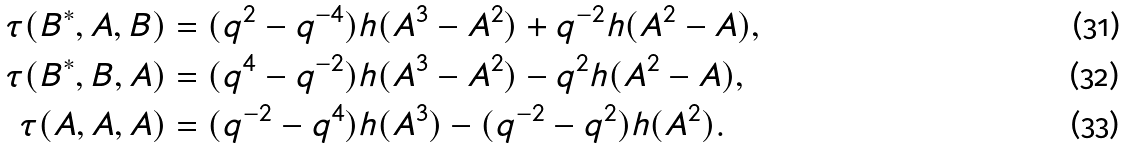Convert formula to latex. <formula><loc_0><loc_0><loc_500><loc_500>\tau ( B ^ { \ast } , A , B ) & = ( q ^ { 2 } - q ^ { - 4 } ) h ( A ^ { 3 } - A ^ { 2 } ) + q ^ { - 2 } h ( A ^ { 2 } - A ) , \\ \tau ( B ^ { \ast } , B , A ) & = ( q ^ { 4 } - q ^ { - 2 } ) h ( A ^ { 3 } - A ^ { 2 } ) - q ^ { 2 } h ( A ^ { 2 } - A ) , \\ \tau ( A , A , A ) & = ( q ^ { - 2 } - q ^ { 4 } ) h ( A ^ { 3 } ) - ( q ^ { - 2 } - q ^ { 2 } ) h ( A ^ { 2 } ) .</formula> 